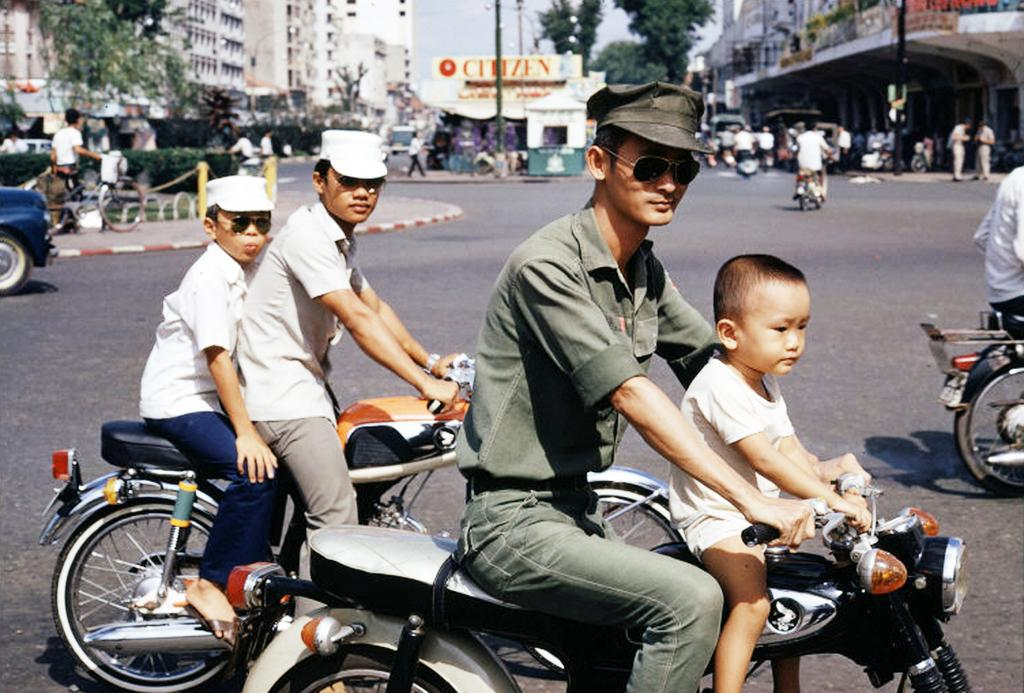What are the people in the image doing? There is a group of persons riding motorcycles in the image. What can be seen in the background of the image? There is a building and trees in the background of the image. Are there any other people visible in the image? Yes, there is a group of people in the background of the image. How many cubs are visible in the image? There are no cubs present in the image. What type of footwear are the people wearing while riding the motorcycles? The image does not provide enough detail to determine the type of footwear the people are wearing. 